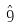Convert formula to latex. <formula><loc_0><loc_0><loc_500><loc_500>\hat { 9 }</formula> 